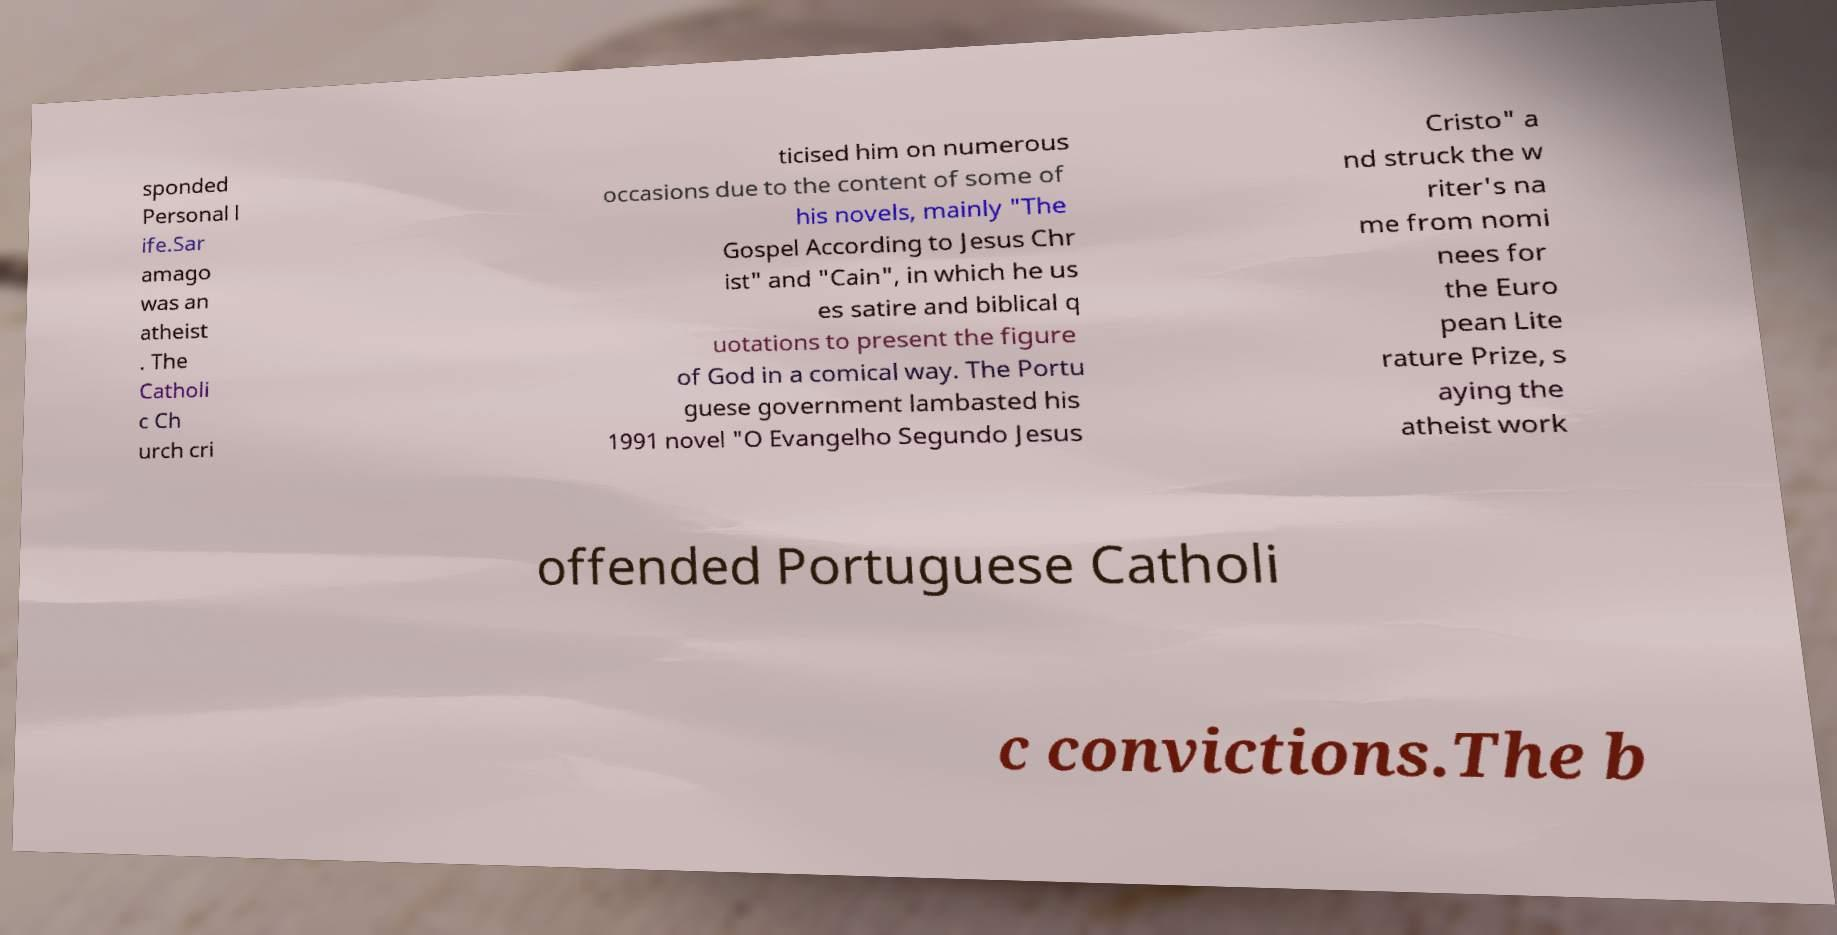Please read and relay the text visible in this image. What does it say? sponded Personal l ife.Sar amago was an atheist . The Catholi c Ch urch cri ticised him on numerous occasions due to the content of some of his novels, mainly "The Gospel According to Jesus Chr ist" and "Cain", in which he us es satire and biblical q uotations to present the figure of God in a comical way. The Portu guese government lambasted his 1991 novel "O Evangelho Segundo Jesus Cristo" a nd struck the w riter's na me from nomi nees for the Euro pean Lite rature Prize, s aying the atheist work offended Portuguese Catholi c convictions.The b 